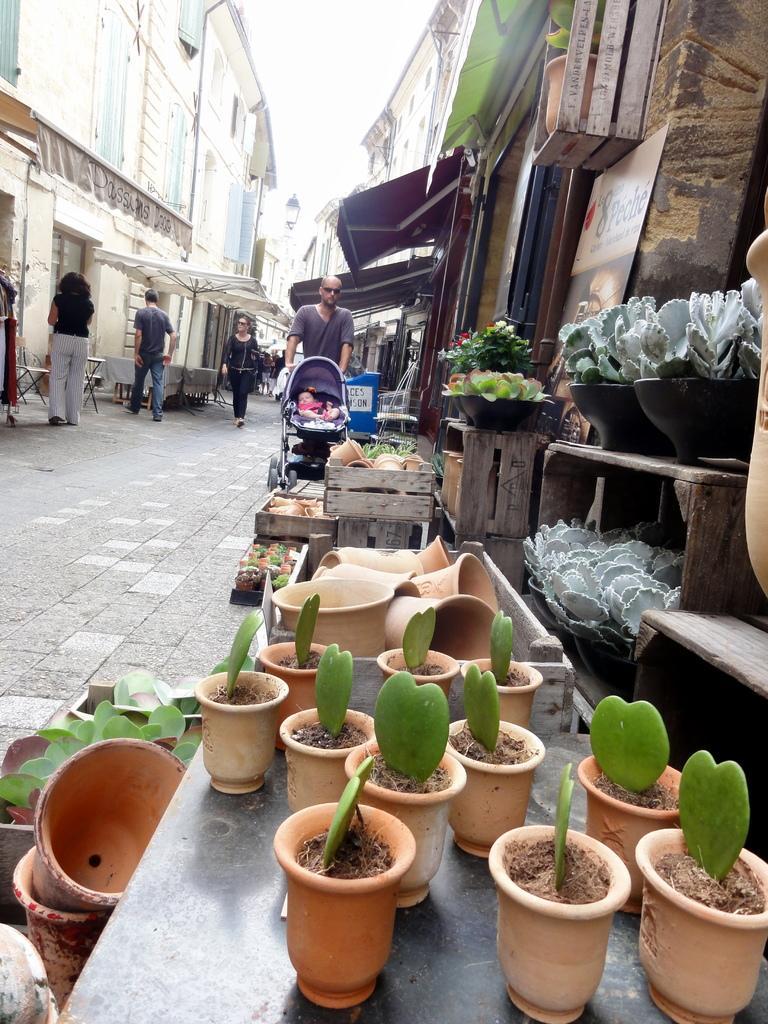Can you describe this image briefly? In this image I can see few plants in pots. In the background I can see few more plants in pots. I can also see number of buildings and I can see few people are standing. 